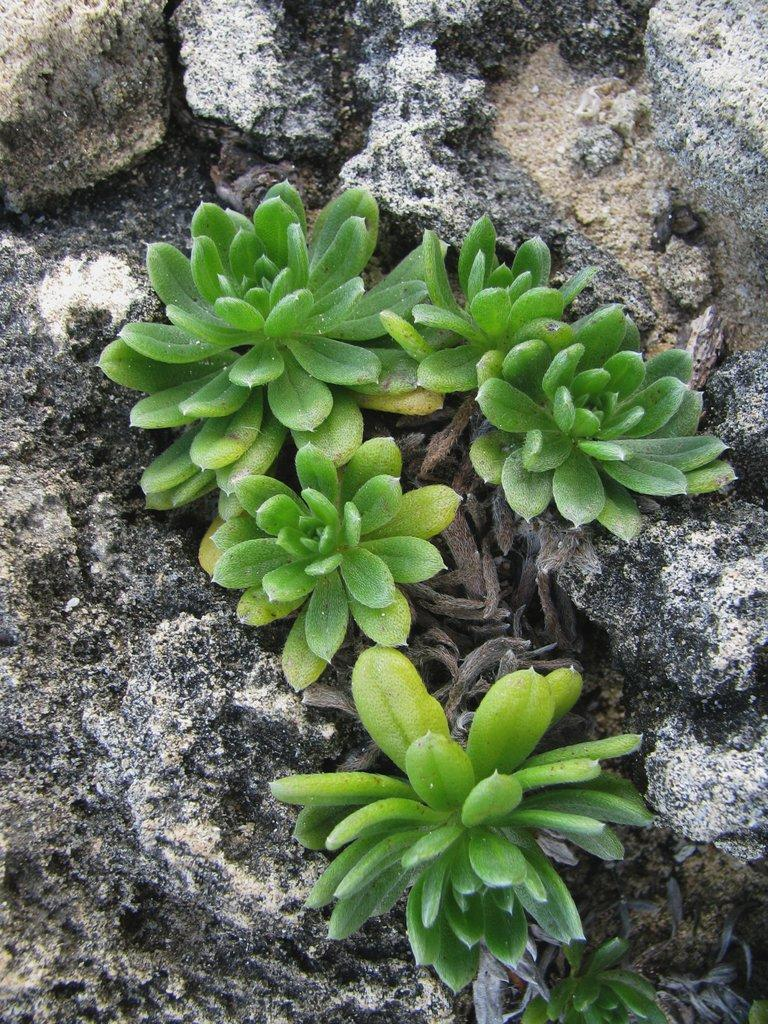What type of living organisms can be seen in the image? Plants can be seen in the image. What other objects are present in the image besides plants? There are rocks in the image. What type of rhythm can be heard coming from the plants in the image? There is no sound or rhythm associated with the plants in the image. 